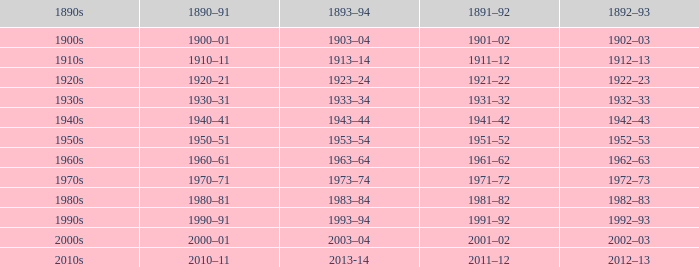What is the year from 1891-92 from the years 1890s to the 1960s? 1961–62. 